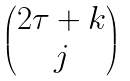Convert formula to latex. <formula><loc_0><loc_0><loc_500><loc_500>\begin{pmatrix} 2 \tau + k \\ j \end{pmatrix}</formula> 